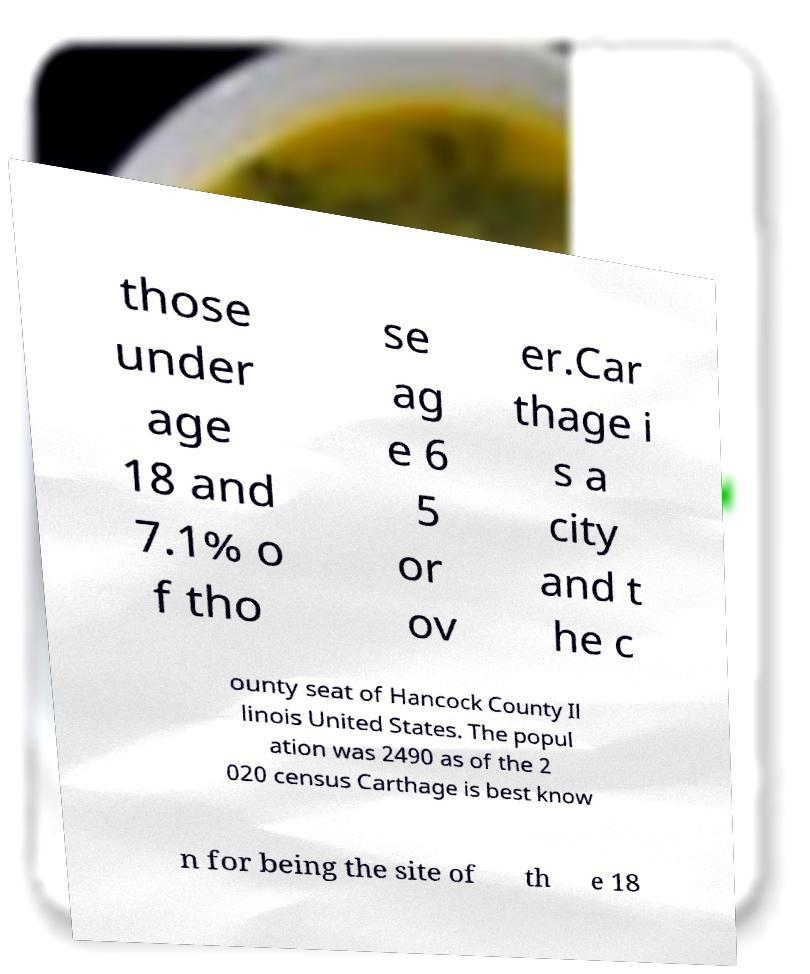Can you read and provide the text displayed in the image?This photo seems to have some interesting text. Can you extract and type it out for me? those under age 18 and 7.1% o f tho se ag e 6 5 or ov er.Car thage i s a city and t he c ounty seat of Hancock County Il linois United States. The popul ation was 2490 as of the 2 020 census Carthage is best know n for being the site of th e 18 